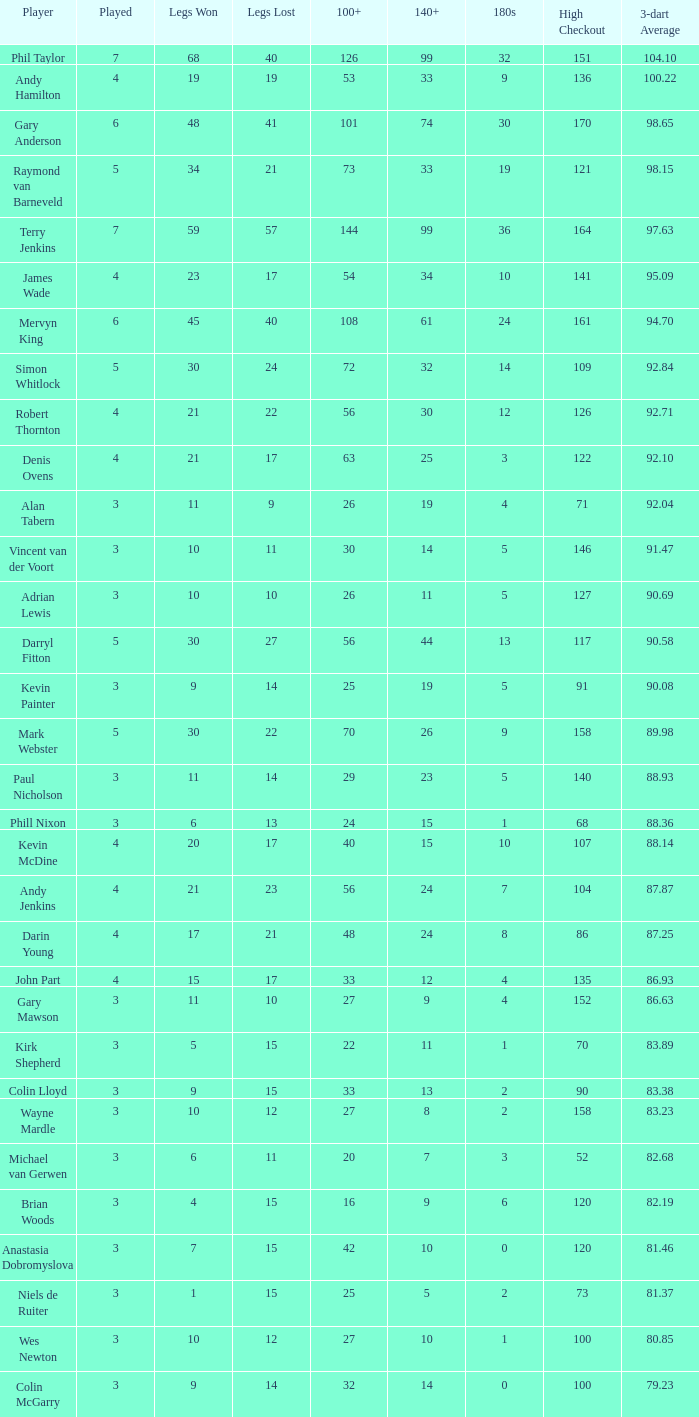What is the count of high checkout when legs lost equals 17, 140+ equals 15, and played exceeds 4? None. 